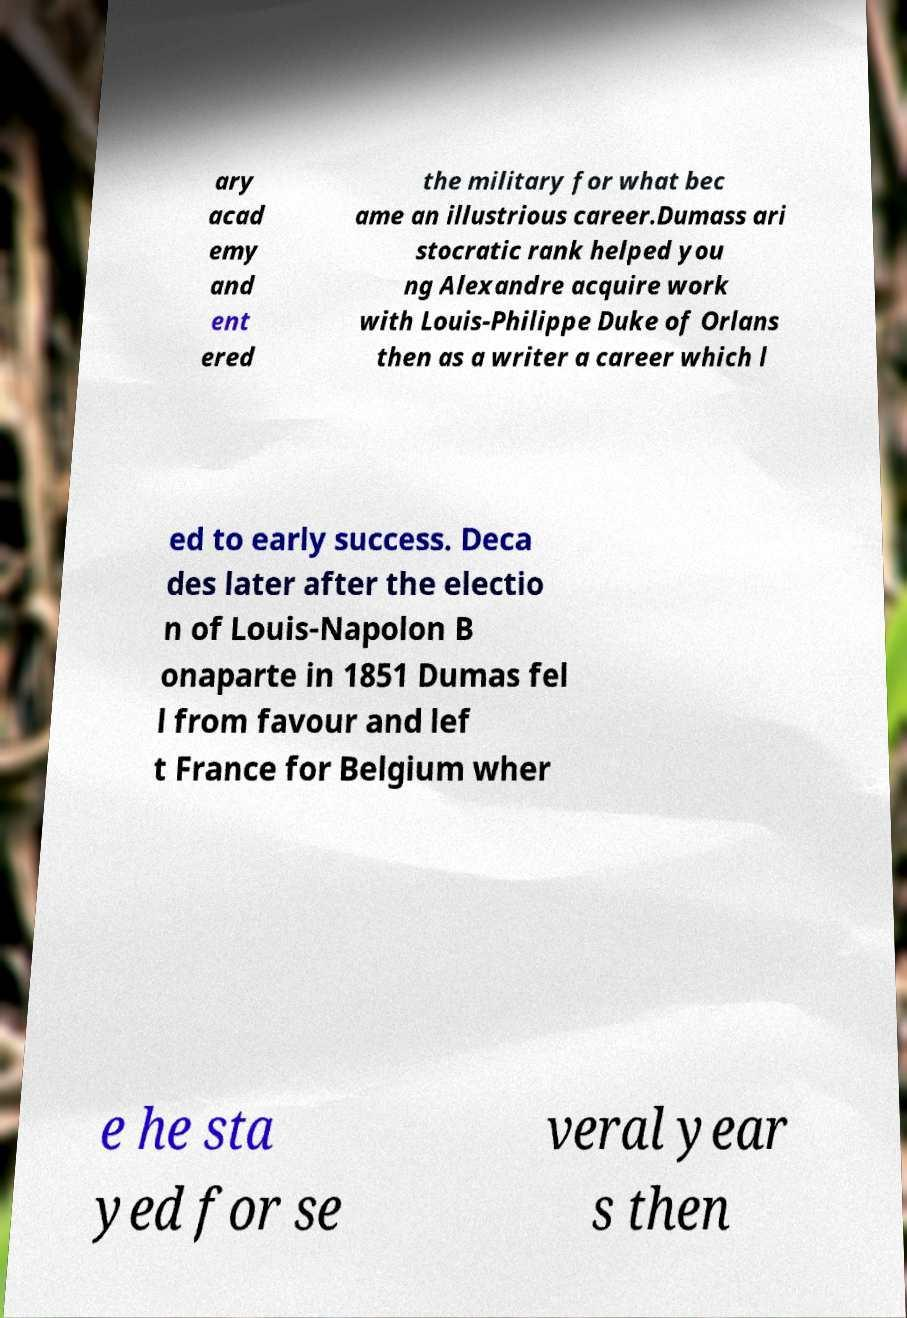Could you extract and type out the text from this image? ary acad emy and ent ered the military for what bec ame an illustrious career.Dumass ari stocratic rank helped you ng Alexandre acquire work with Louis-Philippe Duke of Orlans then as a writer a career which l ed to early success. Deca des later after the electio n of Louis-Napolon B onaparte in 1851 Dumas fel l from favour and lef t France for Belgium wher e he sta yed for se veral year s then 